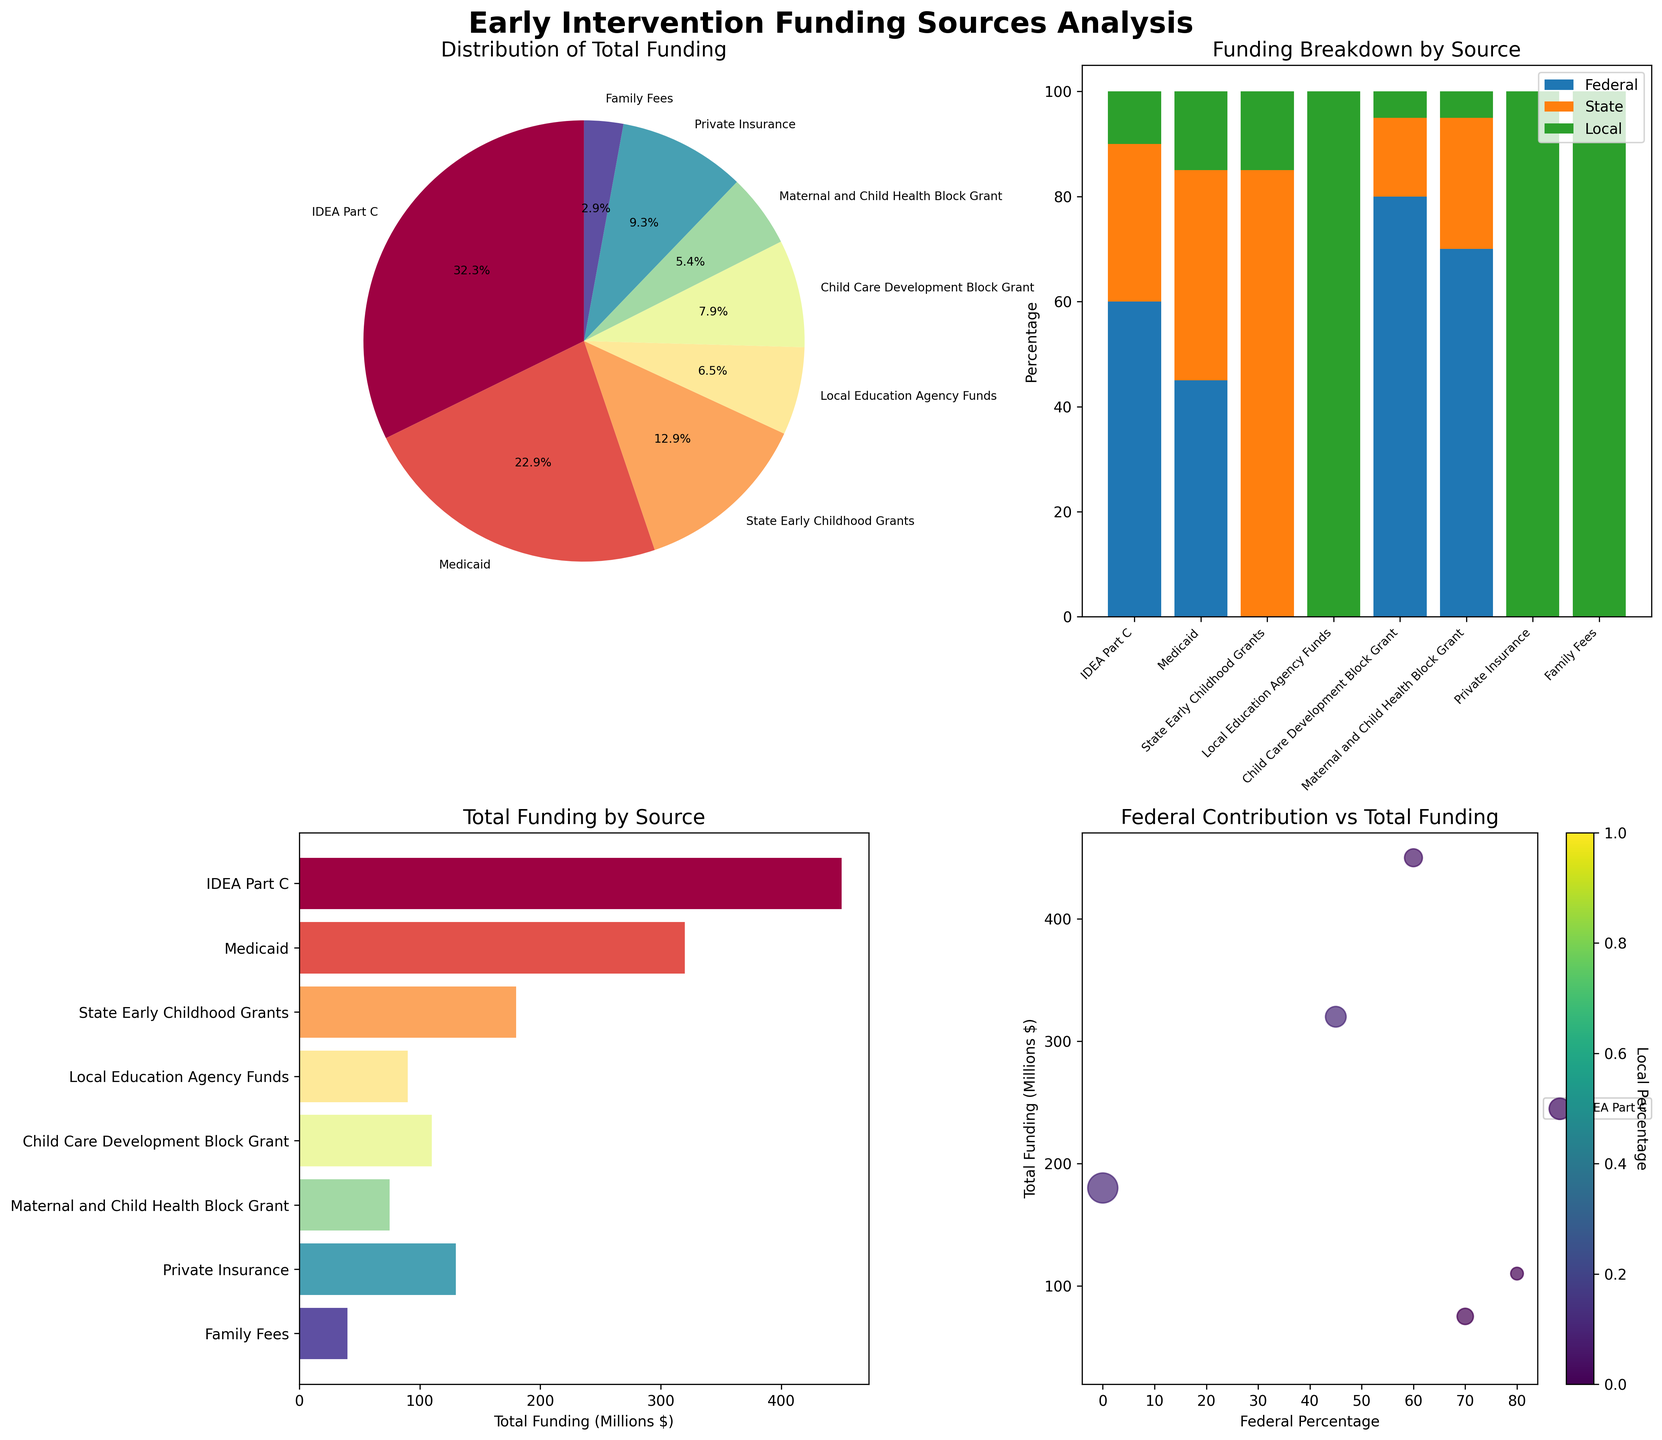Which funding source has the highest percentage of federal funding? From the stacked bar chart, the funding source with the highest federal funding (shown in blue) can be identified. IDEA Part C has the tallest blue section in the stacked bar.
Answer: IDEA Part C How much total funding is provided by Medicaid? Refer to the horizontal bar chart where each bar represents the total funding amount for each source. Find the length of the bar labeled Medicaid.
Answer: 320 Million dollars What percentage of the Child Care Development Block Grant comes from state sources? Look at the stacked bar chart, locate the Child Care Development Block Grant bar, and observe the orange middle section labeled State.
Answer: 15% Which funding source is entirely locally funded? Both the stacked bar chart and the scatter plot can help identify funding sources with 100% local funding, represented by green. Local Education Agency Funds, Private Insurance, and Family Fees have only green sections.
Answer: Local Education Agency Funds, Private Insurance, Family Fees What is the total funding amount provided by State Early Childhood Grants and how much of it is federally funded? Refer to the horizontal bar chart to determine the total funding amount for State Early Childhood Grants. Then, check the stacked bar chart for its federal (blue) section size. State Early Childhood Grants show 0% federal funding.
Answer: 180 Million dollars, 0% Compare the total funding amounts between IDEA Part C and Medicaid. Which one has more funding and by how much? Find the horizontal bars for IDEA Part C and Medicaid and compare their lengths. IDEA Part C: 450 Million, Medicaid: 320 Million. The difference can be calculated by 450 - 320.
Answer: IDEA Part C has 130 Million dollars more How does private insurance's total funding compare to the Child Care Development Block Grant? Compare the lengths of the horizontal bars for Private Insurance and Child Care Development Block Grant. Private Insurance: 130 Million, Child Care Development Block Grant: 110 Million. Private Insurance is 20 Million more.
Answer: Private Insurance has 20 Million dollars more Which funding sources have no federal contribution, and which have no state contribution? From the stacked bar chart, identify funding sources with no blue sections (no federal contribution) and no orange sections (no state contribution). State Early Childhood Grants, Local Education Agency Funds, Private Insurance, and Family Fees have no federal contribution. Local Education Agency Funds, Private Insurance, Family Fees have no state contribution.
Answer: No Federal: State Early Childhood Grants, Local Education Agency Funds, Private Insurance, Family Fees. No State: Local Education Agency Funds, Private Insurance, Family Fees 